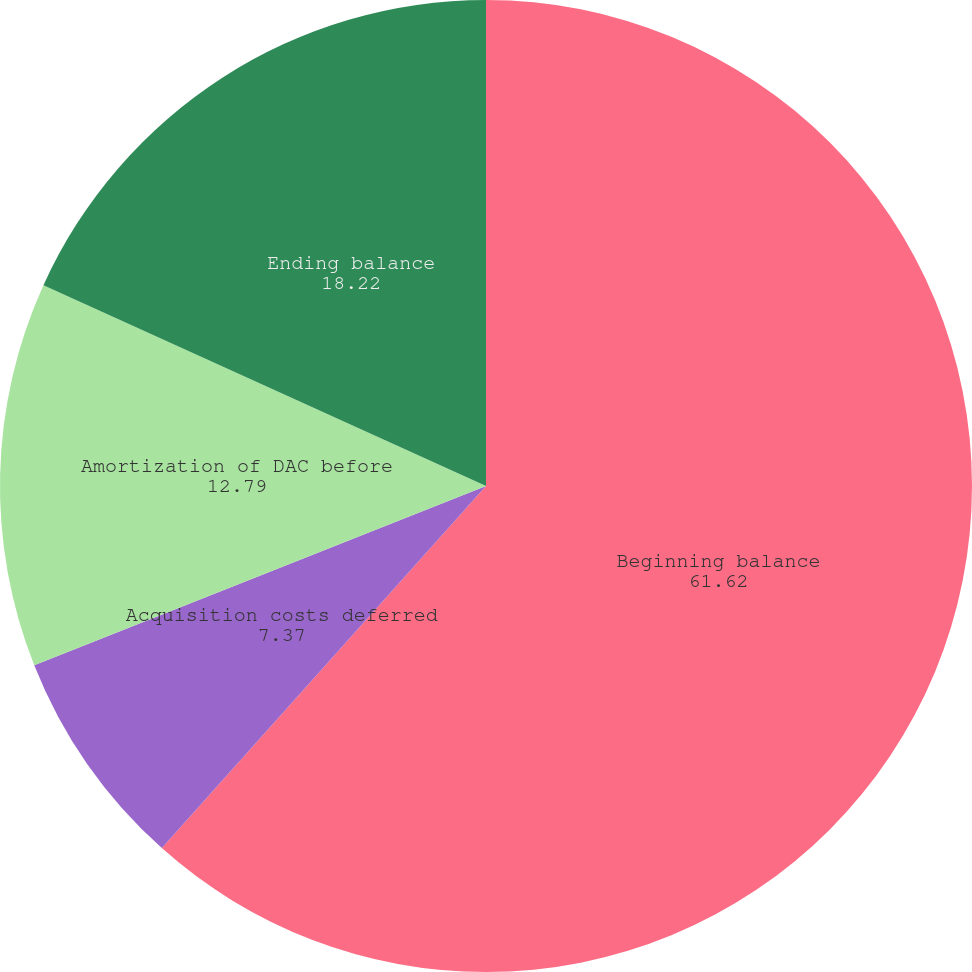Convert chart to OTSL. <chart><loc_0><loc_0><loc_500><loc_500><pie_chart><fcel>Beginning balance<fcel>Acquisition costs deferred<fcel>Amortization of DAC before<fcel>Ending balance<nl><fcel>61.62%<fcel>7.37%<fcel>12.79%<fcel>18.22%<nl></chart> 